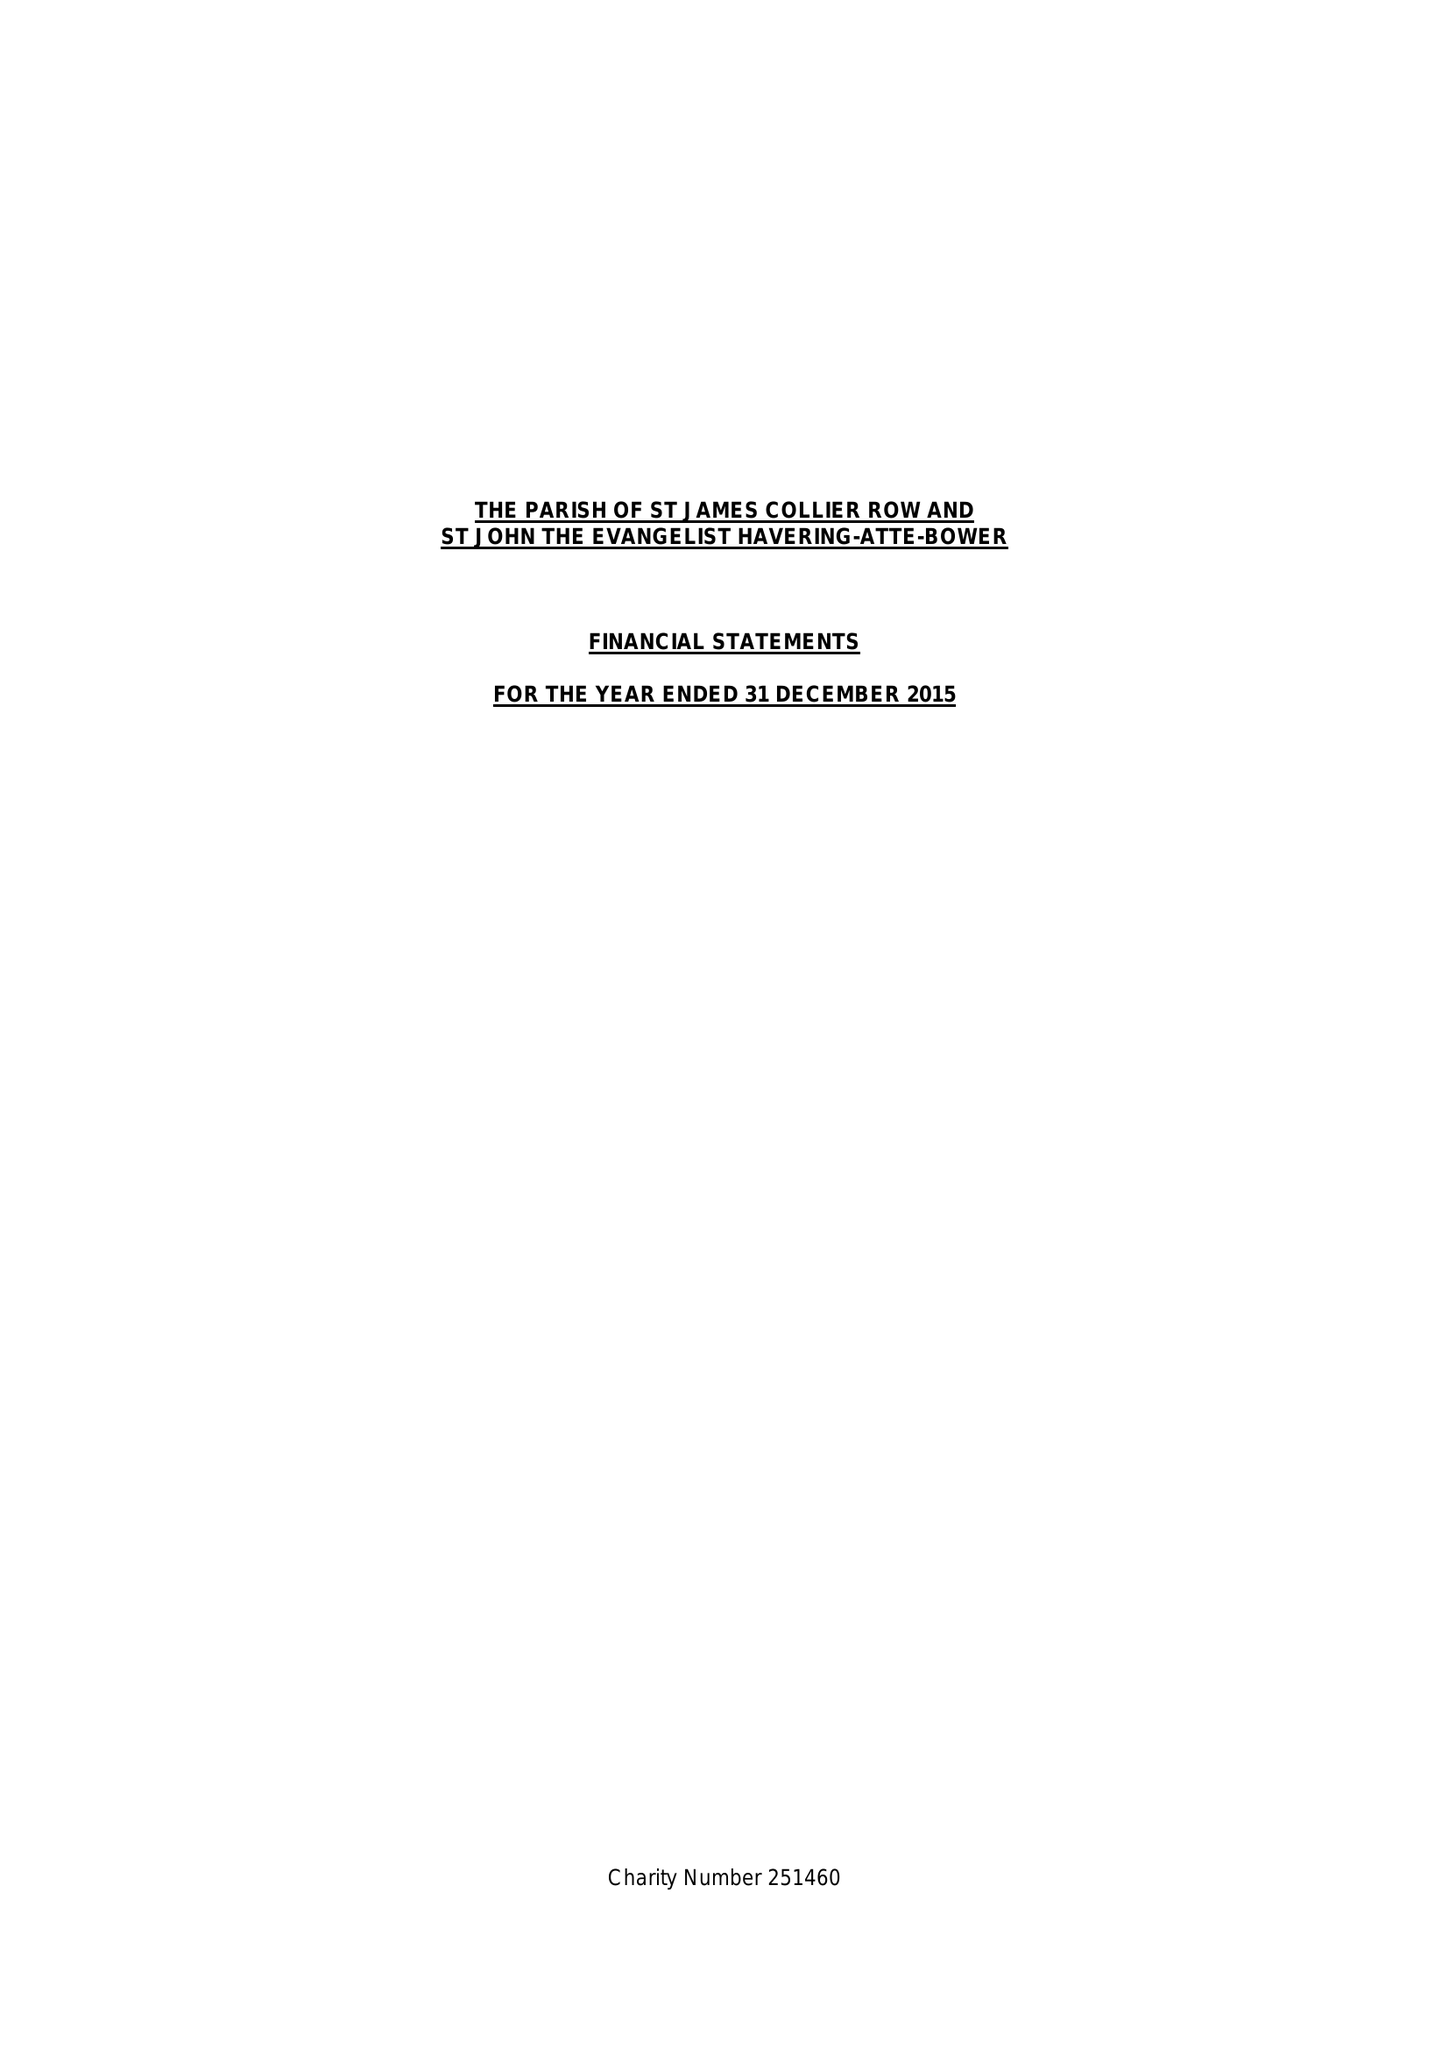What is the value for the address__street_line?
Answer the question using a single word or phrase. 21 LINKS AVENUE 